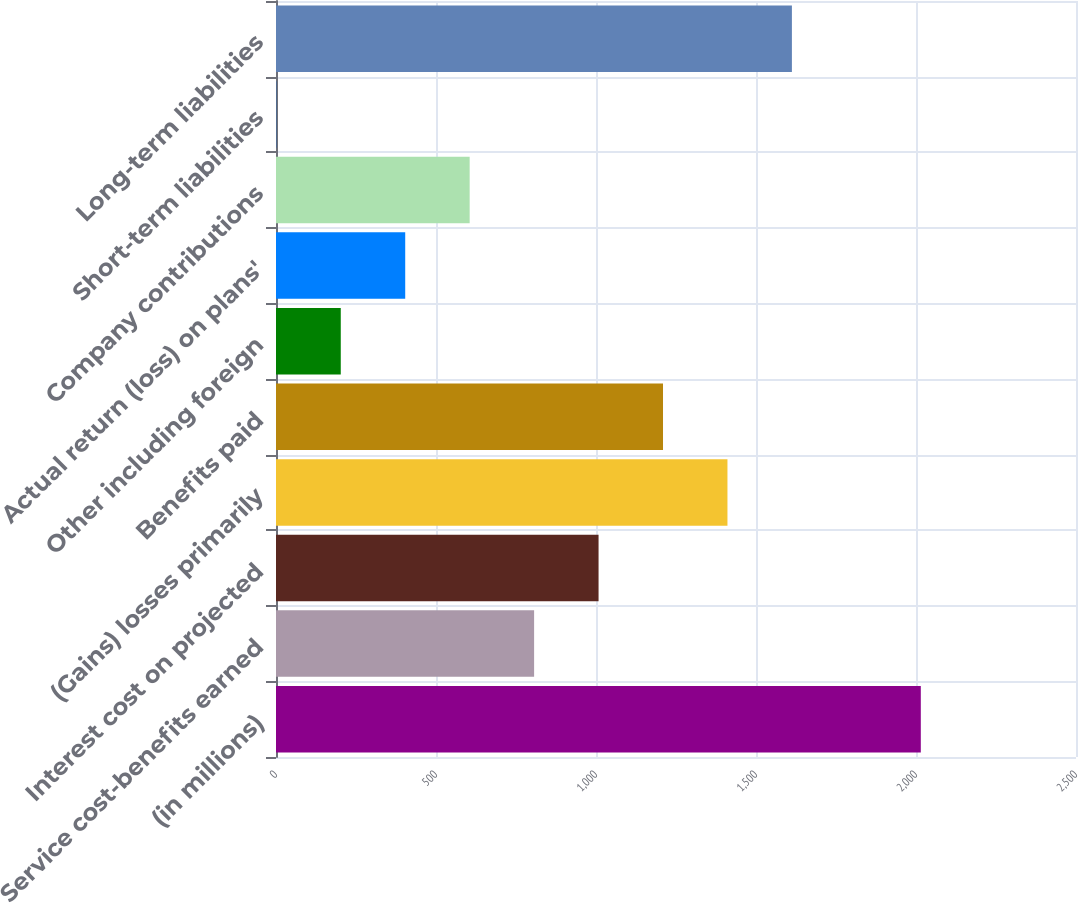Convert chart. <chart><loc_0><loc_0><loc_500><loc_500><bar_chart><fcel>(in millions)<fcel>Service cost-benefits earned<fcel>Interest cost on projected<fcel>(Gains) losses primarily<fcel>Benefits paid<fcel>Other including foreign<fcel>Actual return (loss) on plans'<fcel>Company contributions<fcel>Short-term liabilities<fcel>Long-term liabilities<nl><fcel>2015<fcel>806.6<fcel>1008<fcel>1410.8<fcel>1209.4<fcel>202.4<fcel>403.8<fcel>605.2<fcel>1<fcel>1612.2<nl></chart> 